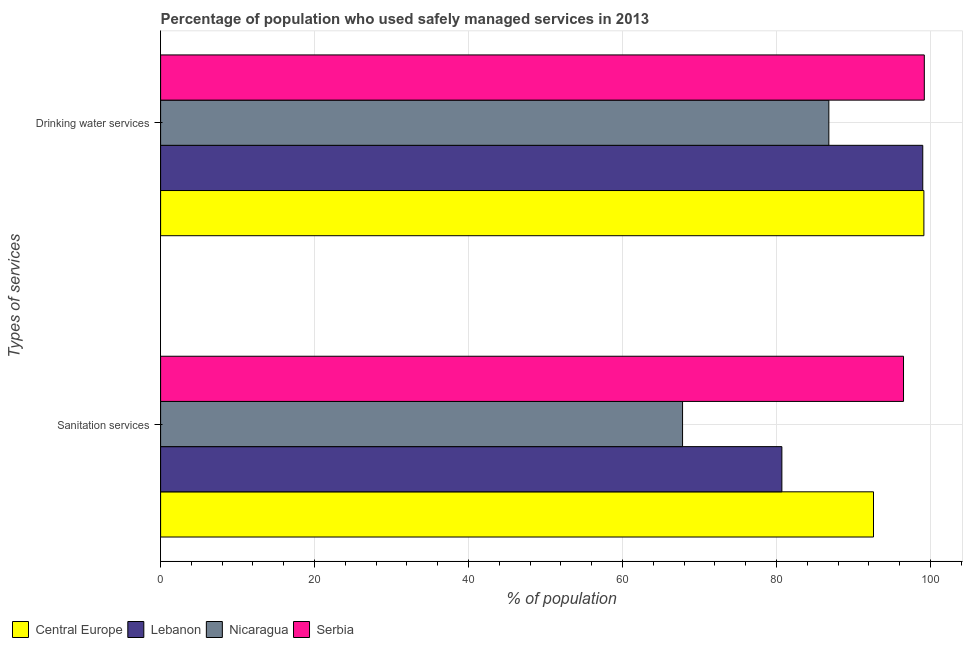How many different coloured bars are there?
Keep it short and to the point. 4. Are the number of bars on each tick of the Y-axis equal?
Offer a very short reply. Yes. What is the label of the 1st group of bars from the top?
Offer a terse response. Drinking water services. What is the percentage of population who used sanitation services in Serbia?
Provide a short and direct response. 96.5. Across all countries, what is the maximum percentage of population who used sanitation services?
Ensure brevity in your answer.  96.5. Across all countries, what is the minimum percentage of population who used drinking water services?
Make the answer very short. 86.8. In which country was the percentage of population who used drinking water services maximum?
Keep it short and to the point. Serbia. In which country was the percentage of population who used drinking water services minimum?
Provide a succinct answer. Nicaragua. What is the total percentage of population who used drinking water services in the graph?
Your answer should be very brief. 384.15. What is the difference between the percentage of population who used sanitation services in Serbia and that in Lebanon?
Offer a very short reply. 15.8. What is the difference between the percentage of population who used sanitation services in Nicaragua and the percentage of population who used drinking water services in Serbia?
Your response must be concise. -31.4. What is the average percentage of population who used sanitation services per country?
Offer a very short reply. 84.4. What is the ratio of the percentage of population who used sanitation services in Central Europe to that in Nicaragua?
Provide a short and direct response. 1.37. Is the percentage of population who used drinking water services in Nicaragua less than that in Central Europe?
Provide a succinct answer. Yes. In how many countries, is the percentage of population who used sanitation services greater than the average percentage of population who used sanitation services taken over all countries?
Make the answer very short. 2. What does the 1st bar from the top in Drinking water services represents?
Ensure brevity in your answer.  Serbia. What does the 2nd bar from the bottom in Sanitation services represents?
Give a very brief answer. Lebanon. Are all the bars in the graph horizontal?
Provide a short and direct response. Yes. Are the values on the major ticks of X-axis written in scientific E-notation?
Provide a short and direct response. No. Does the graph contain any zero values?
Your response must be concise. No. Where does the legend appear in the graph?
Offer a terse response. Bottom left. What is the title of the graph?
Provide a succinct answer. Percentage of population who used safely managed services in 2013. What is the label or title of the X-axis?
Offer a very short reply. % of population. What is the label or title of the Y-axis?
Your response must be concise. Types of services. What is the % of population of Central Europe in Sanitation services?
Give a very brief answer. 92.6. What is the % of population in Lebanon in Sanitation services?
Your answer should be compact. 80.7. What is the % of population of Nicaragua in Sanitation services?
Keep it short and to the point. 67.8. What is the % of population of Serbia in Sanitation services?
Provide a succinct answer. 96.5. What is the % of population of Central Europe in Drinking water services?
Provide a succinct answer. 99.15. What is the % of population in Nicaragua in Drinking water services?
Ensure brevity in your answer.  86.8. What is the % of population of Serbia in Drinking water services?
Your answer should be very brief. 99.2. Across all Types of services, what is the maximum % of population in Central Europe?
Offer a very short reply. 99.15. Across all Types of services, what is the maximum % of population in Nicaragua?
Ensure brevity in your answer.  86.8. Across all Types of services, what is the maximum % of population of Serbia?
Ensure brevity in your answer.  99.2. Across all Types of services, what is the minimum % of population in Central Europe?
Keep it short and to the point. 92.6. Across all Types of services, what is the minimum % of population in Lebanon?
Your answer should be compact. 80.7. Across all Types of services, what is the minimum % of population in Nicaragua?
Give a very brief answer. 67.8. Across all Types of services, what is the minimum % of population of Serbia?
Offer a terse response. 96.5. What is the total % of population in Central Europe in the graph?
Offer a very short reply. 191.75. What is the total % of population of Lebanon in the graph?
Your answer should be very brief. 179.7. What is the total % of population in Nicaragua in the graph?
Offer a terse response. 154.6. What is the total % of population of Serbia in the graph?
Give a very brief answer. 195.7. What is the difference between the % of population of Central Europe in Sanitation services and that in Drinking water services?
Keep it short and to the point. -6.54. What is the difference between the % of population of Lebanon in Sanitation services and that in Drinking water services?
Your response must be concise. -18.3. What is the difference between the % of population in Nicaragua in Sanitation services and that in Drinking water services?
Provide a short and direct response. -19. What is the difference between the % of population of Serbia in Sanitation services and that in Drinking water services?
Provide a short and direct response. -2.7. What is the difference between the % of population in Central Europe in Sanitation services and the % of population in Lebanon in Drinking water services?
Offer a terse response. -6.4. What is the difference between the % of population in Central Europe in Sanitation services and the % of population in Nicaragua in Drinking water services?
Give a very brief answer. 5.8. What is the difference between the % of population of Central Europe in Sanitation services and the % of population of Serbia in Drinking water services?
Your answer should be very brief. -6.6. What is the difference between the % of population of Lebanon in Sanitation services and the % of population of Nicaragua in Drinking water services?
Offer a very short reply. -6.1. What is the difference between the % of population in Lebanon in Sanitation services and the % of population in Serbia in Drinking water services?
Your response must be concise. -18.5. What is the difference between the % of population in Nicaragua in Sanitation services and the % of population in Serbia in Drinking water services?
Offer a very short reply. -31.4. What is the average % of population of Central Europe per Types of services?
Offer a terse response. 95.87. What is the average % of population in Lebanon per Types of services?
Offer a terse response. 89.85. What is the average % of population in Nicaragua per Types of services?
Give a very brief answer. 77.3. What is the average % of population of Serbia per Types of services?
Ensure brevity in your answer.  97.85. What is the difference between the % of population of Central Europe and % of population of Lebanon in Sanitation services?
Give a very brief answer. 11.9. What is the difference between the % of population in Central Europe and % of population in Nicaragua in Sanitation services?
Your answer should be very brief. 24.8. What is the difference between the % of population of Central Europe and % of population of Serbia in Sanitation services?
Keep it short and to the point. -3.9. What is the difference between the % of population of Lebanon and % of population of Nicaragua in Sanitation services?
Offer a terse response. 12.9. What is the difference between the % of population of Lebanon and % of population of Serbia in Sanitation services?
Keep it short and to the point. -15.8. What is the difference between the % of population in Nicaragua and % of population in Serbia in Sanitation services?
Your response must be concise. -28.7. What is the difference between the % of population of Central Europe and % of population of Lebanon in Drinking water services?
Make the answer very short. 0.15. What is the difference between the % of population of Central Europe and % of population of Nicaragua in Drinking water services?
Offer a terse response. 12.35. What is the difference between the % of population in Central Europe and % of population in Serbia in Drinking water services?
Keep it short and to the point. -0.05. What is the difference between the % of population of Lebanon and % of population of Serbia in Drinking water services?
Offer a very short reply. -0.2. What is the ratio of the % of population in Central Europe in Sanitation services to that in Drinking water services?
Offer a terse response. 0.93. What is the ratio of the % of population of Lebanon in Sanitation services to that in Drinking water services?
Ensure brevity in your answer.  0.82. What is the ratio of the % of population of Nicaragua in Sanitation services to that in Drinking water services?
Your answer should be compact. 0.78. What is the ratio of the % of population in Serbia in Sanitation services to that in Drinking water services?
Give a very brief answer. 0.97. What is the difference between the highest and the second highest % of population of Central Europe?
Offer a terse response. 6.54. What is the difference between the highest and the lowest % of population of Central Europe?
Offer a terse response. 6.54. What is the difference between the highest and the lowest % of population in Lebanon?
Your response must be concise. 18.3. What is the difference between the highest and the lowest % of population in Nicaragua?
Provide a succinct answer. 19. 